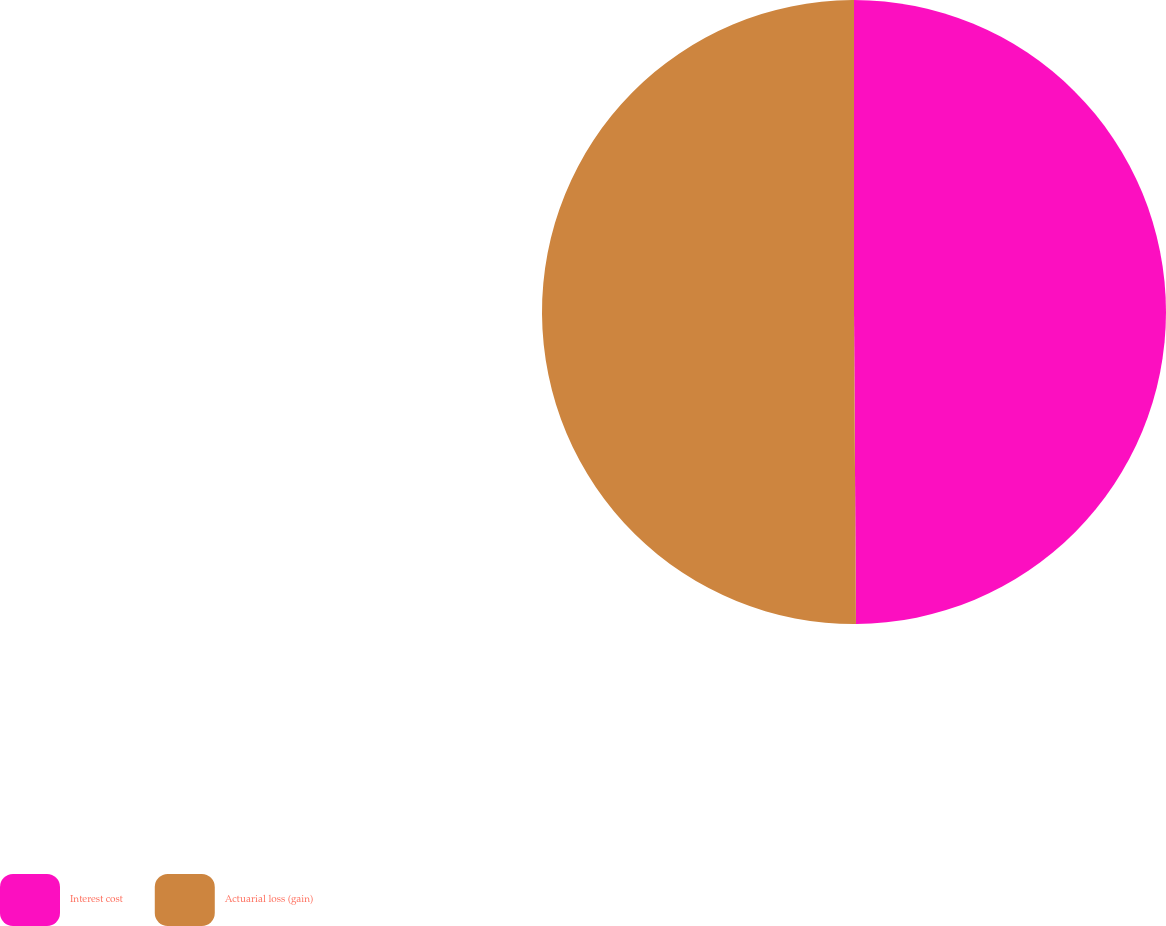Convert chart. <chart><loc_0><loc_0><loc_500><loc_500><pie_chart><fcel>Interest cost<fcel>Actuarial loss (gain)<nl><fcel>49.9%<fcel>50.1%<nl></chart> 